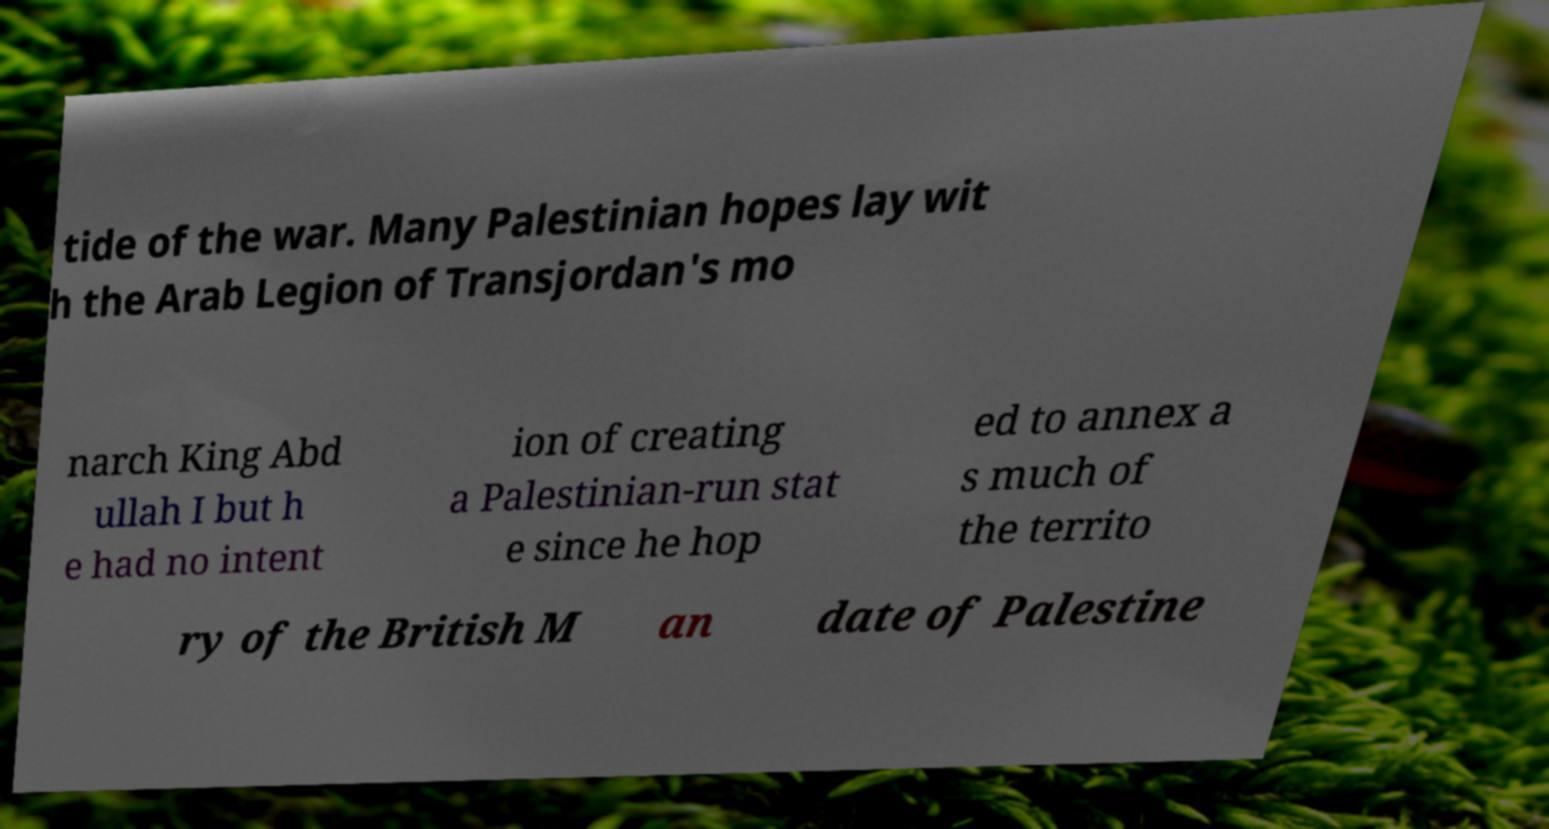Can you read and provide the text displayed in the image?This photo seems to have some interesting text. Can you extract and type it out for me? tide of the war. Many Palestinian hopes lay wit h the Arab Legion of Transjordan's mo narch King Abd ullah I but h e had no intent ion of creating a Palestinian-run stat e since he hop ed to annex a s much of the territo ry of the British M an date of Palestine 